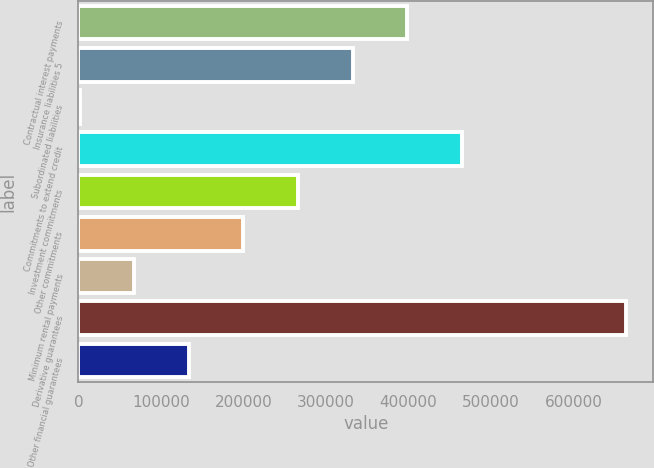Convert chart. <chart><loc_0><loc_0><loc_500><loc_500><bar_chart><fcel>Contractual interest payments<fcel>Insurance liabilities 5<fcel>Subordinated liabilities<fcel>Commitments to extend credit<fcel>Investment commitments<fcel>Other commitments<fcel>Minimum rental payments<fcel>Derivative guarantees<fcel>Other financial guarantees<nl><fcel>398433<fcel>332254<fcel>1360<fcel>464612<fcel>266076<fcel>199897<fcel>67538.9<fcel>663149<fcel>133718<nl></chart> 